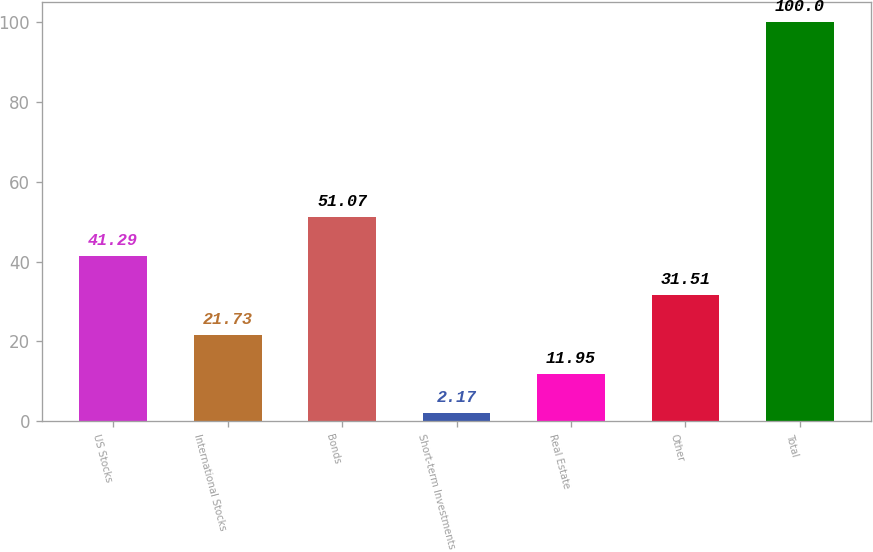Convert chart to OTSL. <chart><loc_0><loc_0><loc_500><loc_500><bar_chart><fcel>US Stocks<fcel>International Stocks<fcel>Bonds<fcel>Short-term Investments<fcel>Real Estate<fcel>Other<fcel>Total<nl><fcel>41.29<fcel>21.73<fcel>51.07<fcel>2.17<fcel>11.95<fcel>31.51<fcel>100<nl></chart> 